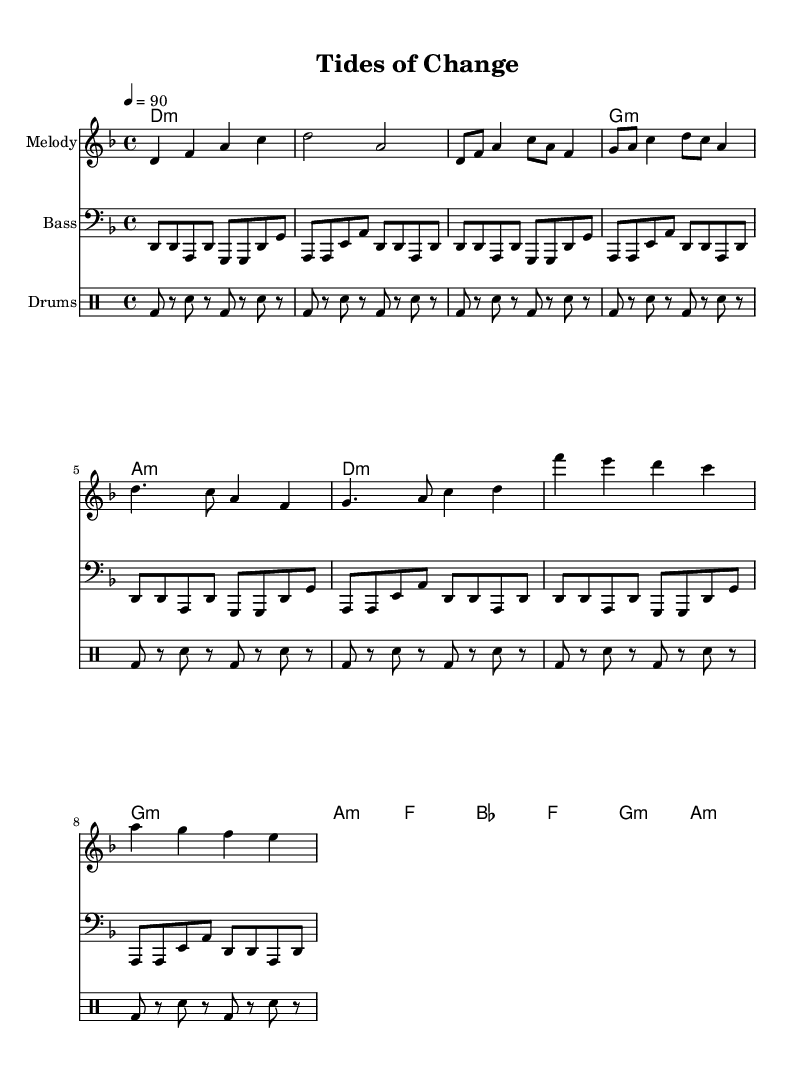What is the key signature of this music? The key signature is D minor, indicated by one flat (B flat). This is often seen at the beginning of the sheet music.
Answer: D minor What is the time signature of this music? The time signature is 4/4, which can be found immediately after the key signature. This means there are four beats in each measure and the quarter note gets one beat.
Answer: 4/4 What is the tempo marking for this piece? The tempo marking is quarter note equals 90, indicating that the piece should be played at a moderate speed. This is generally found above the staff at the beginning of the music.
Answer: 90 How many measures are there in the chorus section? The chorus section consists of four measures, as indicated by counting the measures within the part labeled "Chorus" in the sheet music.
Answer: 4 Which chord appears most frequently in the verse? The D minor chord is featured most frequently; it appears in every line of the verse section. This is determined by examining the harmonies indicated for each measure in the verse.
Answer: D minor What type of drum pattern is used throughout the piece? The drum pattern consists of a kick drum (bd) and snare drum (sn) in a simple alternating rhythm, typical of hip-hop beats. This is visible in the drum part notation.
Answer: Alternating kick and snare What is the overall thematic message of the song based on the title? The title "Tides of Change" suggests a focus on environmental issues affecting oceans and marine life. This is inferred from the thematic content of conscious hip-hop, which often addresses social and ecological concerns.
Answer: Environmental issues 